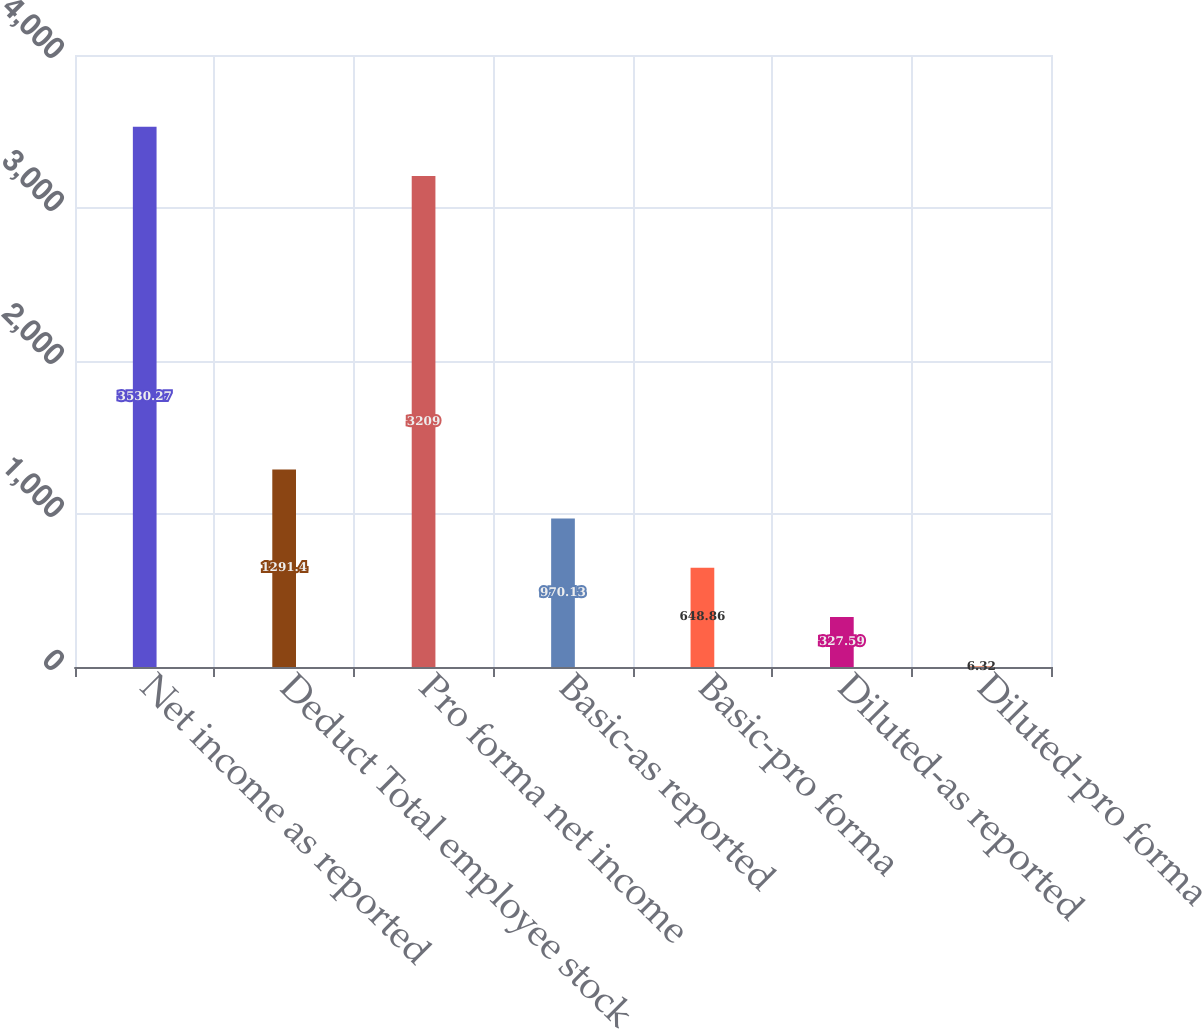<chart> <loc_0><loc_0><loc_500><loc_500><bar_chart><fcel>Net income as reported<fcel>Deduct Total employee stock<fcel>Pro forma net income<fcel>Basic-as reported<fcel>Basic-pro forma<fcel>Diluted-as reported<fcel>Diluted-pro forma<nl><fcel>3530.27<fcel>1291.4<fcel>3209<fcel>970.13<fcel>648.86<fcel>327.59<fcel>6.32<nl></chart> 